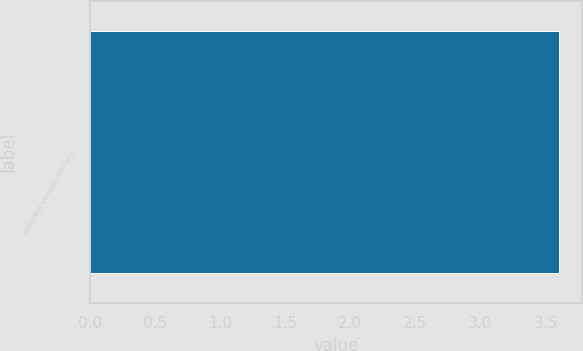Convert chart to OTSL. <chart><loc_0><loc_0><loc_500><loc_500><bar_chart><fcel>Weighted-average discount<nl><fcel>3.6<nl></chart> 